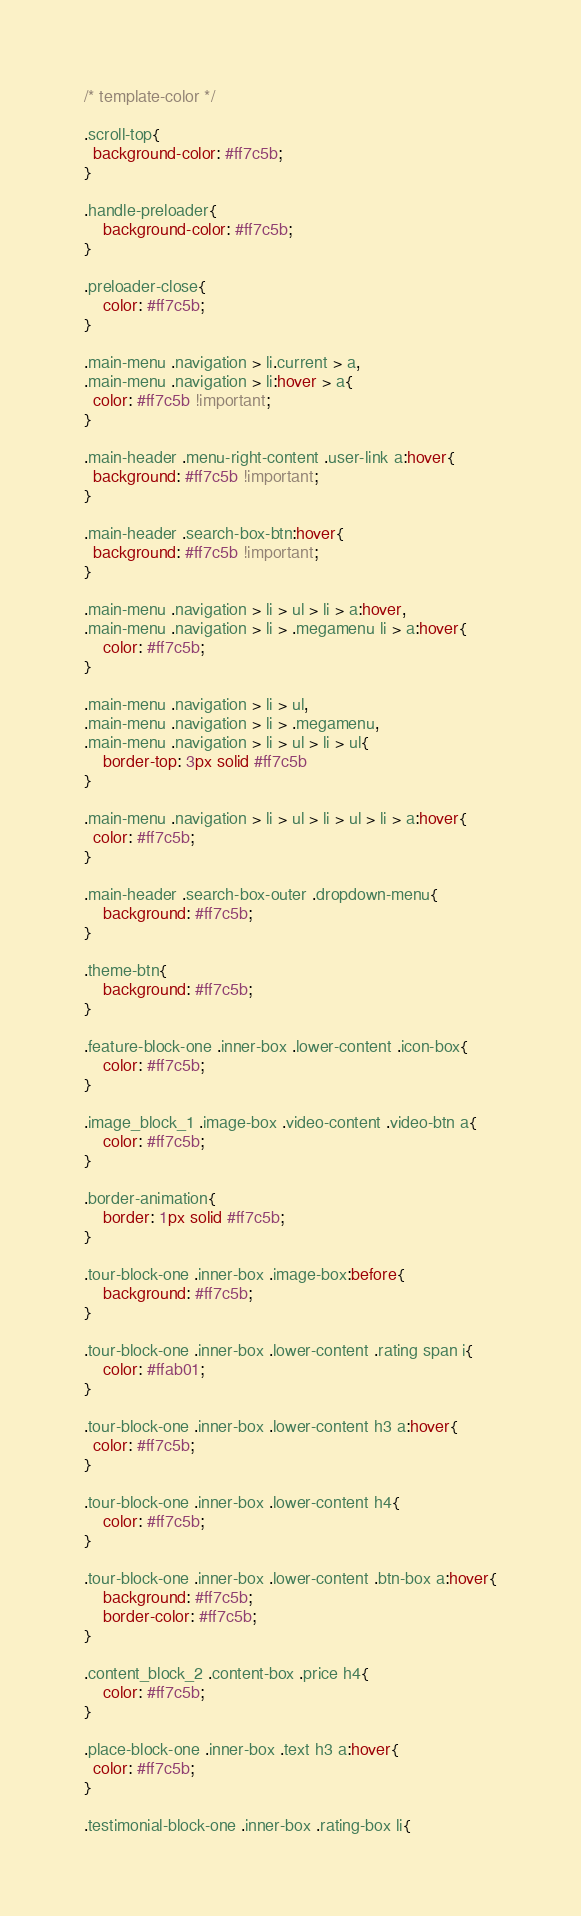Convert code to text. <code><loc_0><loc_0><loc_500><loc_500><_CSS_>/* template-color */

.scroll-top{
  background-color: #ff7c5b;
}

.handle-preloader{
	background-color: #ff7c5b;
}

.preloader-close{
	color: #ff7c5b;
}

.main-menu .navigation > li.current > a,
.main-menu .navigation > li:hover > a{
  color: #ff7c5b !important;
}

.main-header .menu-right-content .user-link a:hover{
  background: #ff7c5b !important;
}

.main-header .search-box-btn:hover{
  background: #ff7c5b !important;
}

.main-menu .navigation > li > ul > li > a:hover,
.main-menu .navigation > li > .megamenu li > a:hover{
	color: #ff7c5b;
}

.main-menu .navigation > li > ul, 
.main-menu .navigation > li > .megamenu,
.main-menu .navigation > li > ul > li > ul{
	border-top: 3px solid #ff7c5b
}

.main-menu .navigation > li > ul > li > ul > li > a:hover{
  color: #ff7c5b;
}

.main-header .search-box-outer .dropdown-menu{
	background: #ff7c5b;
}

.theme-btn{
	background: #ff7c5b;
}

.feature-block-one .inner-box .lower-content .icon-box{
	color: #ff7c5b;
}

.image_block_1 .image-box .video-content .video-btn a{
	color: #ff7c5b;
}

.border-animation{
	border: 1px solid #ff7c5b;
}

.tour-block-one .inner-box .image-box:before{
	background: #ff7c5b;
}

.tour-block-one .inner-box .lower-content .rating span i{
	color: #ffab01;
}

.tour-block-one .inner-box .lower-content h3 a:hover{
  color: #ff7c5b;
}

.tour-block-one .inner-box .lower-content h4{
	color: #ff7c5b;
}

.tour-block-one .inner-box .lower-content .btn-box a:hover{
	background: #ff7c5b;
	border-color: #ff7c5b;
}

.content_block_2 .content-box .price h4{
	color: #ff7c5b;
}

.place-block-one .inner-box .text h3 a:hover{
  color: #ff7c5b;
}

.testimonial-block-one .inner-box .rating-box li{</code> 